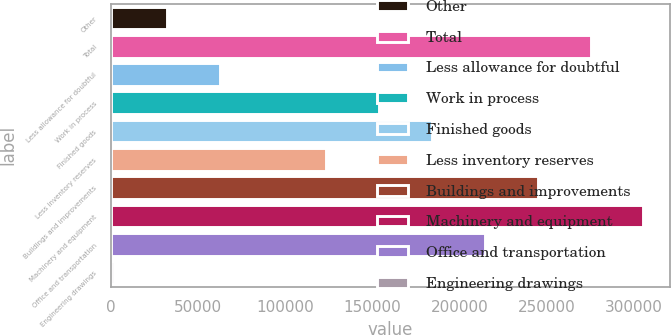Convert chart. <chart><loc_0><loc_0><loc_500><loc_500><bar_chart><fcel>Other<fcel>Total<fcel>Less allowance for doubtful<fcel>Work in process<fcel>Finished goods<fcel>Less inventory reserves<fcel>Buildings and improvements<fcel>Machinery and equipment<fcel>Office and transportation<fcel>Engineering drawings<nl><fcel>32220.3<fcel>275031<fcel>62571.6<fcel>153626<fcel>183977<fcel>123274<fcel>244679<fcel>305382<fcel>214328<fcel>1869<nl></chart> 